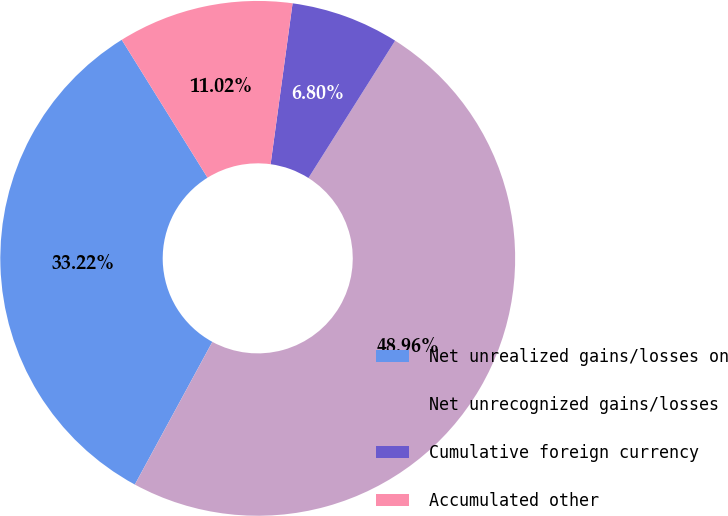Convert chart to OTSL. <chart><loc_0><loc_0><loc_500><loc_500><pie_chart><fcel>Net unrealized gains/losses on<fcel>Net unrecognized gains/losses<fcel>Cumulative foreign currency<fcel>Accumulated other<nl><fcel>33.22%<fcel>48.96%<fcel>6.8%<fcel>11.02%<nl></chart> 